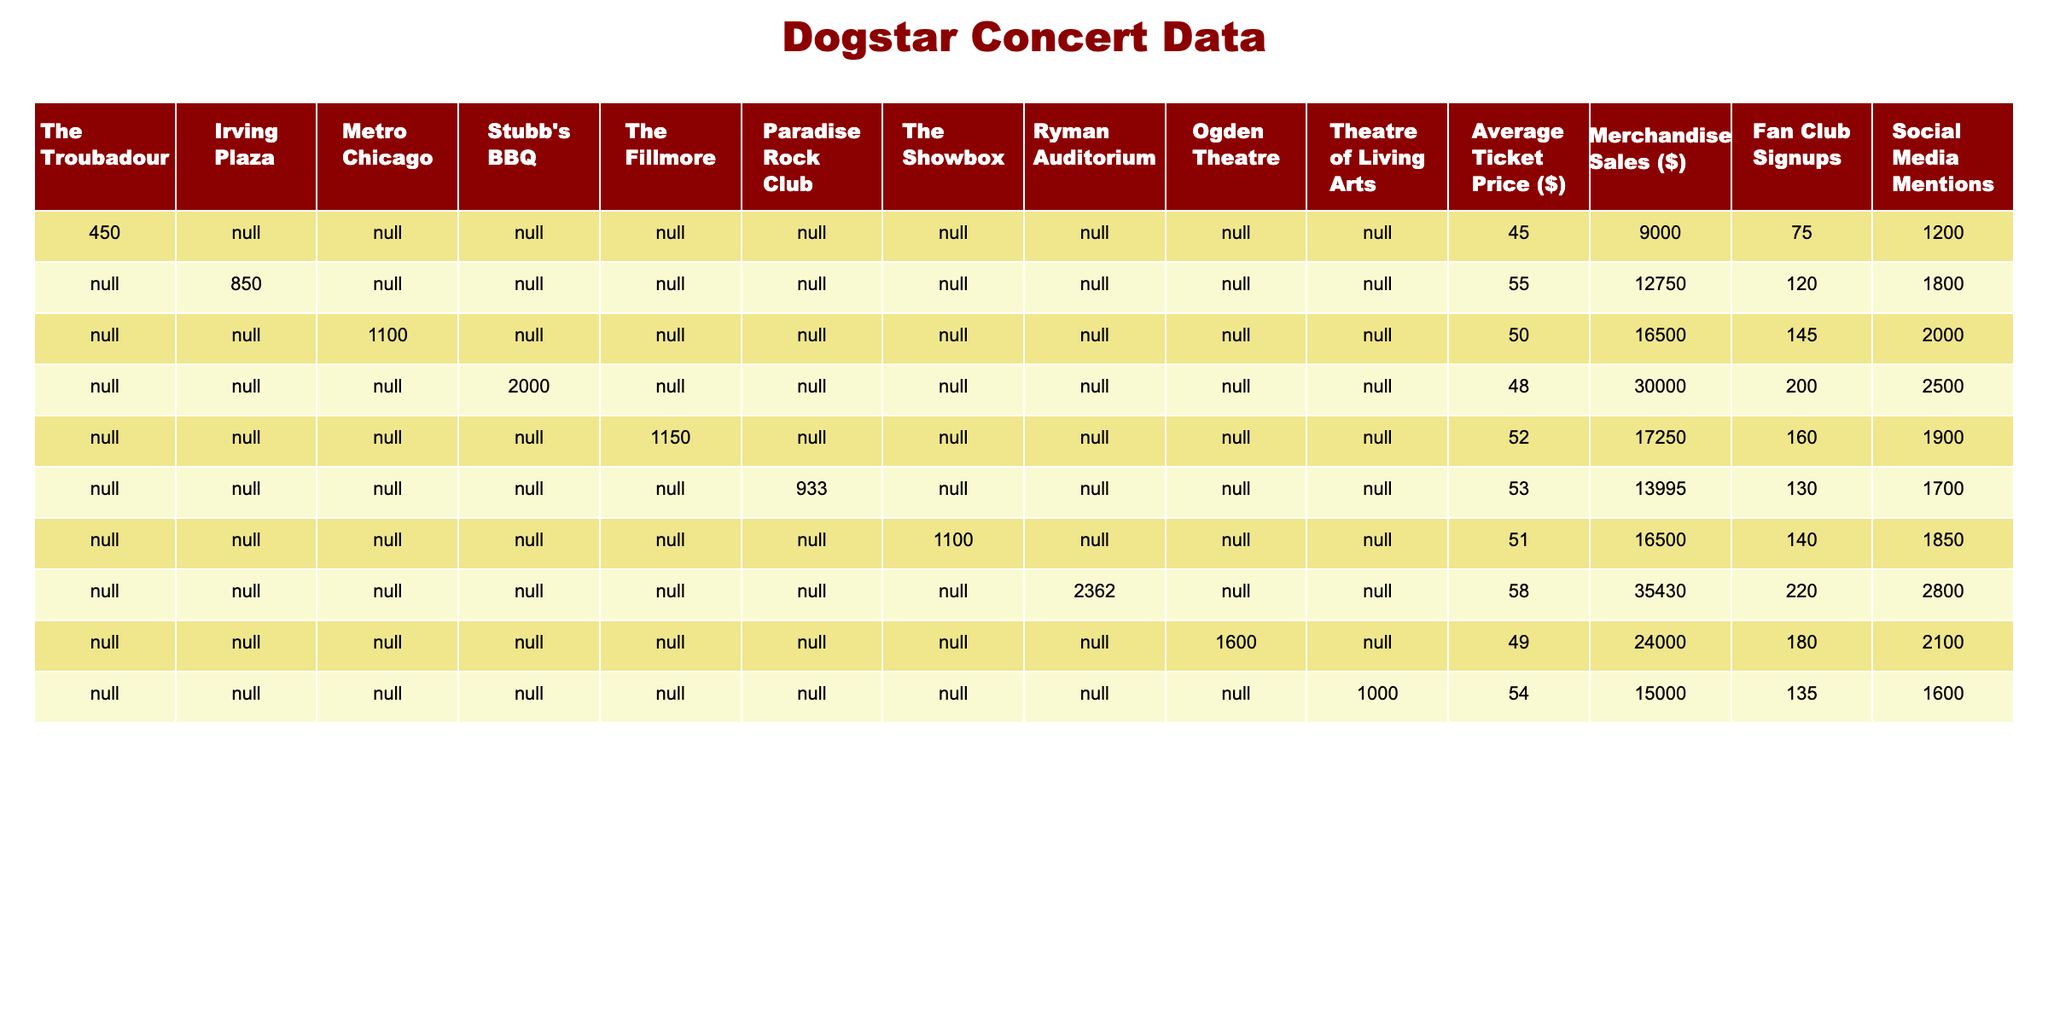What is the total merchandise sales from the Austin venue? The merchandise sales for the Austin venue in 2023 is $30,000.
Answer: $30,000 Which venue had the highest number of fan club signups? The Nashville venue had the highest number of fan club signups with 220.
Answer: 220 What is the average ticket price across all venues? Summing the ticket prices (45 + 55 + 50 + 48 + 52 + 53 + 51 + 58 + 49 + 54) gives 465. There are 10 venues, so the average ticket price is 465 / 10 = 46.5.
Answer: 46.5 Was the merchandise sales in Chicago greater than in Philadelphia? Merchandise sales in Chicago was $16,500 and in Philadelphia was $15,000. Since 16,500 > 15,000, Chicago's merchandise sales are greater.
Answer: Yes What is the difference in social media mentions between the highest and lowest venues? The highest mentions are from Nashville with 2,800 and the lowest is Boston with 1,600. The difference is 2,800 - 1,600 = 1,200.
Answer: 1,200 How many more fans signed up in total in New York and Philadelphia compared to Los Angeles? New York had 120 signups and Philadelphia had 135. Summing these gives 120 + 135 = 255. For Los Angeles, there were 75 signups. The difference is 255 - 75 = 180 more signups.
Answer: 180 What venue had the second lowest average ticket price, and what was that price? The average ticket prices are: Los Angeles ($45), New York ($55), Chicago ($50), Austin ($48), San Francisco ($52), Boston ($53), Seattle ($51), Nashville ($58), Denver ($49), Philadelphia ($54). The second lowest is from Austin at $48.
Answer: Austin, $48 Which venue had the least attendance? The attendance figures are recorded only for venues, and The Troubadour had 450, which is the only attendance data available here.
Answer: 450 What is the total merchandise sales for all venues? Adding all merchandise sales gives a total of $90,000 (sum: 9000 + 12750 + 16500 + 30000 + 17250 + 13995 + 16500 + 35430 + 24000 + 15000).
Answer: $90,000 Did the average ticket price in San Francisco exceed $50? The average ticket price in San Francisco is $52, which is greater than $50. Therefore, the statement is true.
Answer: Yes 